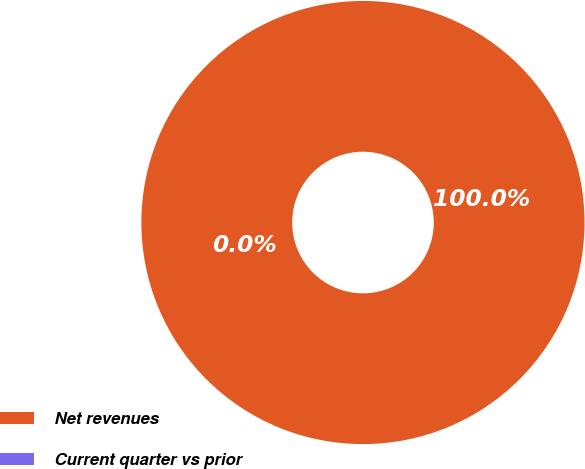Convert chart. <chart><loc_0><loc_0><loc_500><loc_500><pie_chart><fcel>Net revenues<fcel>Current quarter vs prior<nl><fcel>100.0%<fcel>0.0%<nl></chart> 